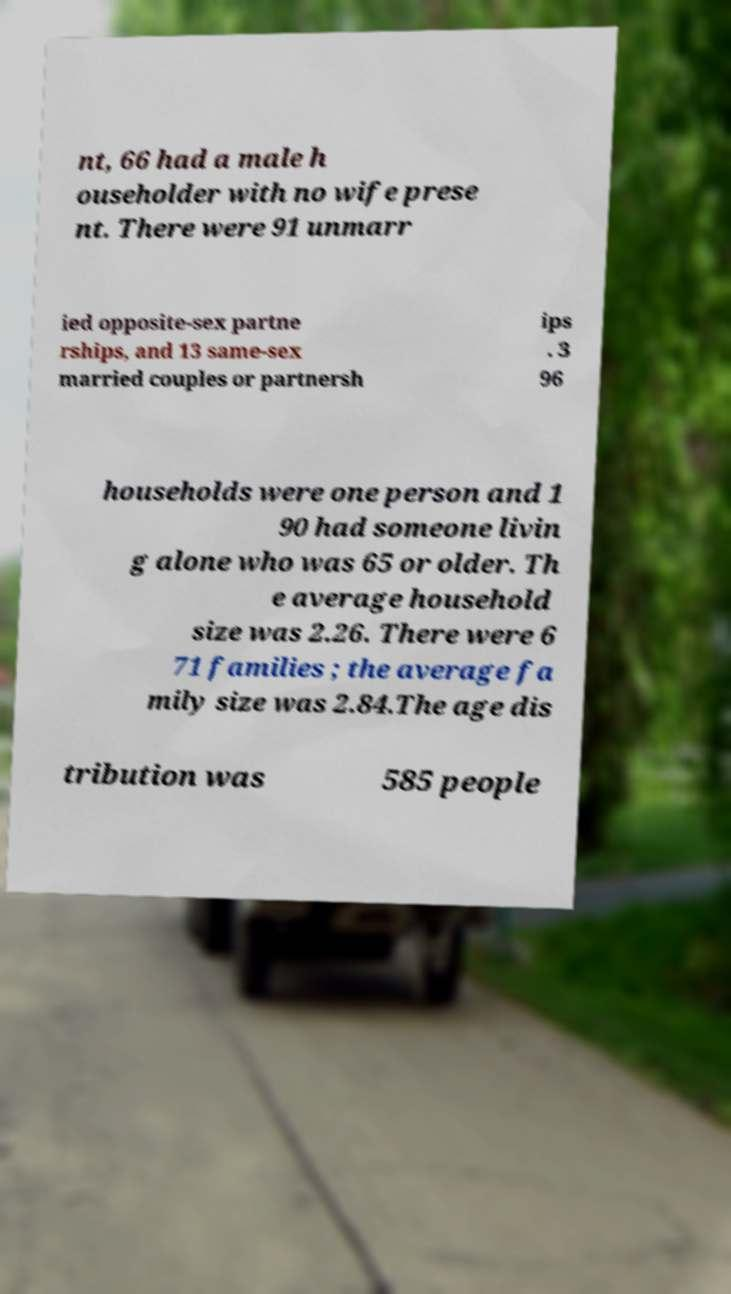Can you accurately transcribe the text from the provided image for me? nt, 66 had a male h ouseholder with no wife prese nt. There were 91 unmarr ied opposite-sex partne rships, and 13 same-sex married couples or partnersh ips . 3 96 households were one person and 1 90 had someone livin g alone who was 65 or older. Th e average household size was 2.26. There were 6 71 families ; the average fa mily size was 2.84.The age dis tribution was 585 people 